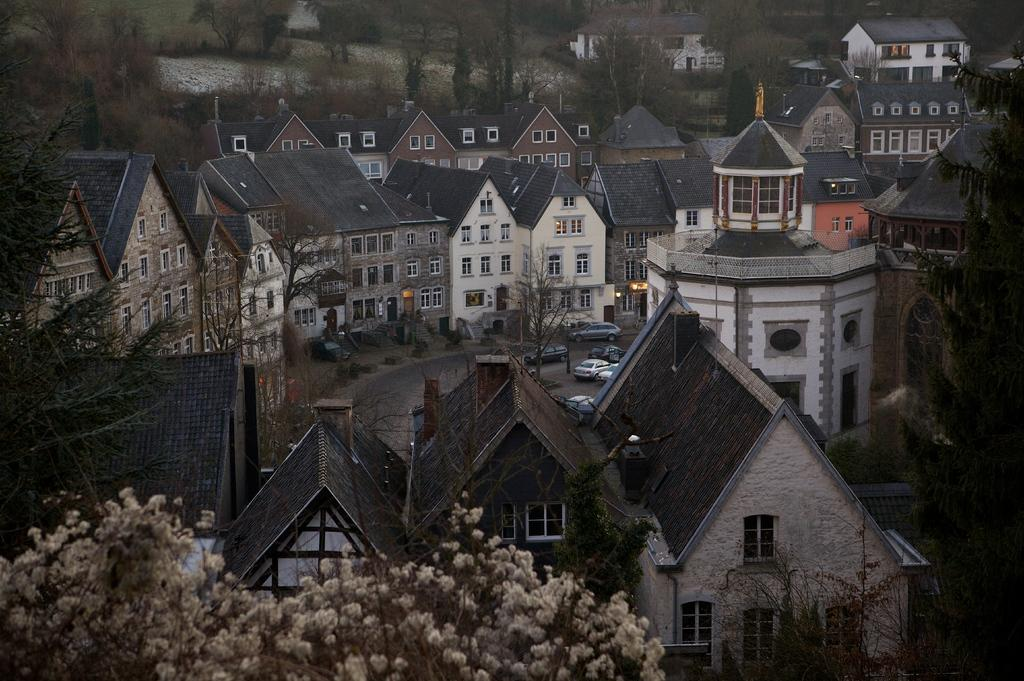What type of vegetation can be seen in the image? There are trees in the image. What type of structures are present in the image? There are houses in the image. What type of vehicles can be seen on the road in the image? There are cars on the road in the image. How does the beggar react to the quarter in the image? There is no beggar or quarter present in the image. What type of reaction can be seen from the trees in the image? Trees do not exhibit reactions, as they are inanimate objects. 